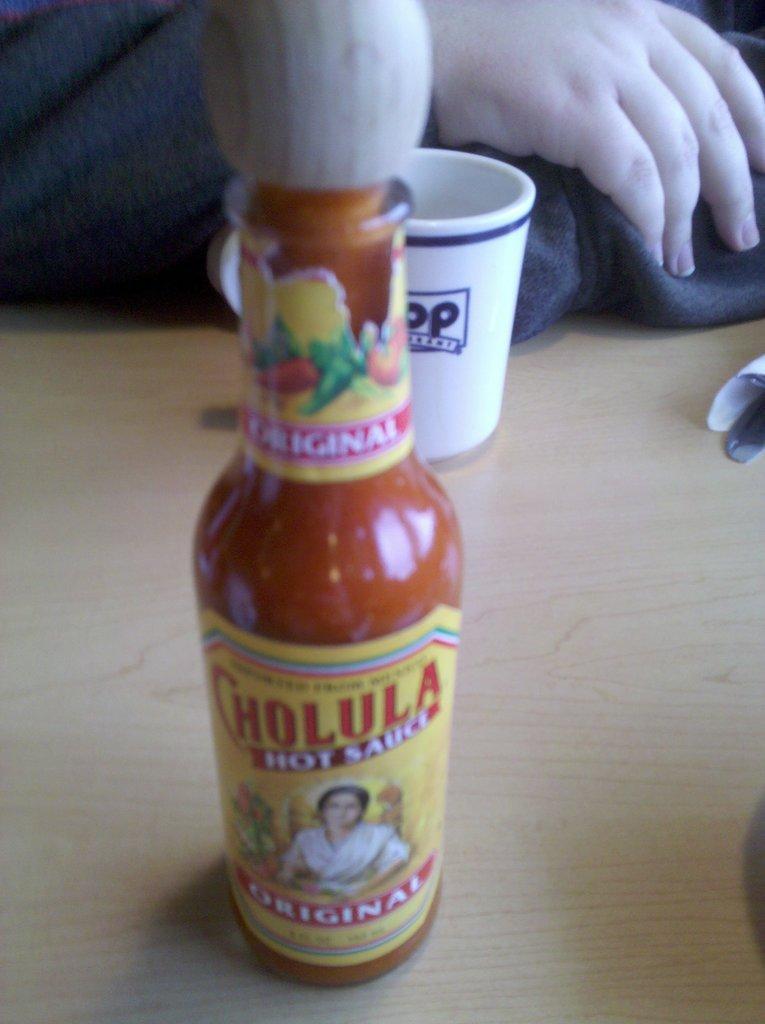In one or two sentences, can you explain what this image depicts? In this image we can see a bottle and a cup on the table, and here a person is sitting. 